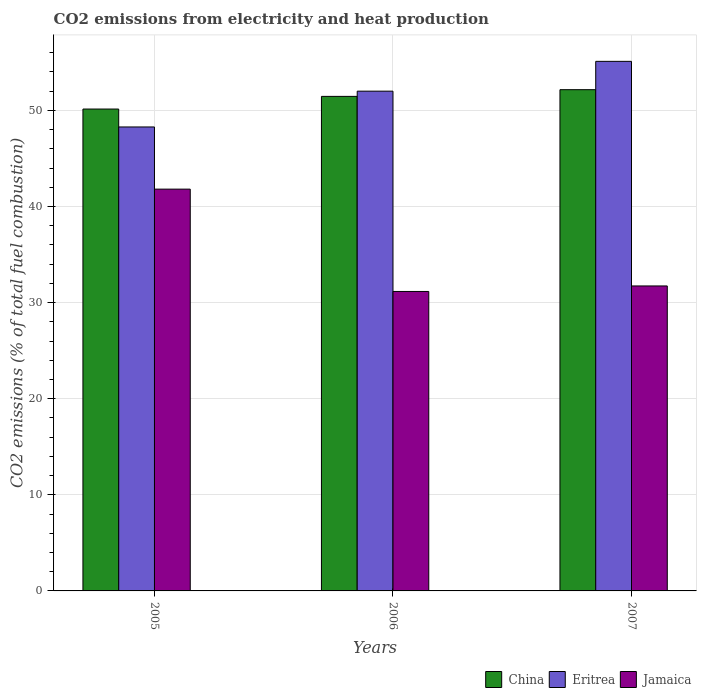How many groups of bars are there?
Offer a very short reply. 3. Are the number of bars on each tick of the X-axis equal?
Your response must be concise. Yes. How many bars are there on the 1st tick from the right?
Your response must be concise. 3. What is the label of the 1st group of bars from the left?
Make the answer very short. 2005. What is the amount of CO2 emitted in China in 2006?
Your response must be concise. 51.46. Across all years, what is the maximum amount of CO2 emitted in Eritrea?
Offer a very short reply. 55.1. Across all years, what is the minimum amount of CO2 emitted in Eritrea?
Provide a short and direct response. 48.28. In which year was the amount of CO2 emitted in China minimum?
Ensure brevity in your answer.  2005. What is the total amount of CO2 emitted in Eritrea in the graph?
Offer a terse response. 155.38. What is the difference between the amount of CO2 emitted in China in 2006 and that in 2007?
Provide a short and direct response. -0.7. What is the difference between the amount of CO2 emitted in Jamaica in 2005 and the amount of CO2 emitted in Eritrea in 2006?
Provide a short and direct response. -10.19. What is the average amount of CO2 emitted in China per year?
Your answer should be very brief. 51.25. In the year 2007, what is the difference between the amount of CO2 emitted in Eritrea and amount of CO2 emitted in China?
Your answer should be compact. 2.95. What is the ratio of the amount of CO2 emitted in Eritrea in 2005 to that in 2007?
Your answer should be compact. 0.88. Is the difference between the amount of CO2 emitted in Eritrea in 2005 and 2007 greater than the difference between the amount of CO2 emitted in China in 2005 and 2007?
Keep it short and to the point. No. What is the difference between the highest and the second highest amount of CO2 emitted in Eritrea?
Offer a very short reply. 3.1. What is the difference between the highest and the lowest amount of CO2 emitted in Jamaica?
Provide a short and direct response. 10.65. What does the 3rd bar from the left in 2006 represents?
Offer a terse response. Jamaica. What does the 1st bar from the right in 2006 represents?
Your answer should be very brief. Jamaica. What is the difference between two consecutive major ticks on the Y-axis?
Your answer should be compact. 10. Does the graph contain grids?
Give a very brief answer. Yes. How are the legend labels stacked?
Keep it short and to the point. Horizontal. What is the title of the graph?
Offer a terse response. CO2 emissions from electricity and heat production. Does "Middle East & North Africa (all income levels)" appear as one of the legend labels in the graph?
Your answer should be very brief. No. What is the label or title of the Y-axis?
Offer a terse response. CO2 emissions (% of total fuel combustion). What is the CO2 emissions (% of total fuel combustion) in China in 2005?
Offer a very short reply. 50.14. What is the CO2 emissions (% of total fuel combustion) of Eritrea in 2005?
Give a very brief answer. 48.28. What is the CO2 emissions (% of total fuel combustion) in Jamaica in 2005?
Offer a terse response. 41.81. What is the CO2 emissions (% of total fuel combustion) of China in 2006?
Your response must be concise. 51.46. What is the CO2 emissions (% of total fuel combustion) in Eritrea in 2006?
Your answer should be very brief. 52. What is the CO2 emissions (% of total fuel combustion) of Jamaica in 2006?
Make the answer very short. 31.16. What is the CO2 emissions (% of total fuel combustion) of China in 2007?
Keep it short and to the point. 52.15. What is the CO2 emissions (% of total fuel combustion) of Eritrea in 2007?
Give a very brief answer. 55.1. What is the CO2 emissions (% of total fuel combustion) of Jamaica in 2007?
Give a very brief answer. 31.73. Across all years, what is the maximum CO2 emissions (% of total fuel combustion) of China?
Offer a terse response. 52.15. Across all years, what is the maximum CO2 emissions (% of total fuel combustion) in Eritrea?
Offer a very short reply. 55.1. Across all years, what is the maximum CO2 emissions (% of total fuel combustion) in Jamaica?
Give a very brief answer. 41.81. Across all years, what is the minimum CO2 emissions (% of total fuel combustion) in China?
Your answer should be compact. 50.14. Across all years, what is the minimum CO2 emissions (% of total fuel combustion) in Eritrea?
Make the answer very short. 48.28. Across all years, what is the minimum CO2 emissions (% of total fuel combustion) of Jamaica?
Keep it short and to the point. 31.16. What is the total CO2 emissions (% of total fuel combustion) of China in the graph?
Provide a short and direct response. 153.75. What is the total CO2 emissions (% of total fuel combustion) of Eritrea in the graph?
Offer a very short reply. 155.38. What is the total CO2 emissions (% of total fuel combustion) in Jamaica in the graph?
Offer a very short reply. 104.7. What is the difference between the CO2 emissions (% of total fuel combustion) in China in 2005 and that in 2006?
Your answer should be compact. -1.32. What is the difference between the CO2 emissions (% of total fuel combustion) of Eritrea in 2005 and that in 2006?
Offer a terse response. -3.72. What is the difference between the CO2 emissions (% of total fuel combustion) in Jamaica in 2005 and that in 2006?
Make the answer very short. 10.65. What is the difference between the CO2 emissions (% of total fuel combustion) of China in 2005 and that in 2007?
Give a very brief answer. -2.02. What is the difference between the CO2 emissions (% of total fuel combustion) of Eritrea in 2005 and that in 2007?
Your answer should be very brief. -6.83. What is the difference between the CO2 emissions (% of total fuel combustion) in Jamaica in 2005 and that in 2007?
Ensure brevity in your answer.  10.07. What is the difference between the CO2 emissions (% of total fuel combustion) of China in 2006 and that in 2007?
Provide a succinct answer. -0.7. What is the difference between the CO2 emissions (% of total fuel combustion) of Eritrea in 2006 and that in 2007?
Your answer should be compact. -3.1. What is the difference between the CO2 emissions (% of total fuel combustion) of Jamaica in 2006 and that in 2007?
Offer a very short reply. -0.57. What is the difference between the CO2 emissions (% of total fuel combustion) in China in 2005 and the CO2 emissions (% of total fuel combustion) in Eritrea in 2006?
Keep it short and to the point. -1.86. What is the difference between the CO2 emissions (% of total fuel combustion) in China in 2005 and the CO2 emissions (% of total fuel combustion) in Jamaica in 2006?
Your answer should be very brief. 18.98. What is the difference between the CO2 emissions (% of total fuel combustion) in Eritrea in 2005 and the CO2 emissions (% of total fuel combustion) in Jamaica in 2006?
Offer a very short reply. 17.12. What is the difference between the CO2 emissions (% of total fuel combustion) in China in 2005 and the CO2 emissions (% of total fuel combustion) in Eritrea in 2007?
Provide a short and direct response. -4.96. What is the difference between the CO2 emissions (% of total fuel combustion) of China in 2005 and the CO2 emissions (% of total fuel combustion) of Jamaica in 2007?
Make the answer very short. 18.41. What is the difference between the CO2 emissions (% of total fuel combustion) of Eritrea in 2005 and the CO2 emissions (% of total fuel combustion) of Jamaica in 2007?
Ensure brevity in your answer.  16.54. What is the difference between the CO2 emissions (% of total fuel combustion) in China in 2006 and the CO2 emissions (% of total fuel combustion) in Eritrea in 2007?
Keep it short and to the point. -3.64. What is the difference between the CO2 emissions (% of total fuel combustion) in China in 2006 and the CO2 emissions (% of total fuel combustion) in Jamaica in 2007?
Offer a very short reply. 19.72. What is the difference between the CO2 emissions (% of total fuel combustion) in Eritrea in 2006 and the CO2 emissions (% of total fuel combustion) in Jamaica in 2007?
Offer a very short reply. 20.27. What is the average CO2 emissions (% of total fuel combustion) of China per year?
Provide a succinct answer. 51.25. What is the average CO2 emissions (% of total fuel combustion) of Eritrea per year?
Keep it short and to the point. 51.79. What is the average CO2 emissions (% of total fuel combustion) of Jamaica per year?
Make the answer very short. 34.9. In the year 2005, what is the difference between the CO2 emissions (% of total fuel combustion) of China and CO2 emissions (% of total fuel combustion) of Eritrea?
Give a very brief answer. 1.86. In the year 2005, what is the difference between the CO2 emissions (% of total fuel combustion) in China and CO2 emissions (% of total fuel combustion) in Jamaica?
Provide a short and direct response. 8.33. In the year 2005, what is the difference between the CO2 emissions (% of total fuel combustion) of Eritrea and CO2 emissions (% of total fuel combustion) of Jamaica?
Ensure brevity in your answer.  6.47. In the year 2006, what is the difference between the CO2 emissions (% of total fuel combustion) of China and CO2 emissions (% of total fuel combustion) of Eritrea?
Keep it short and to the point. -0.54. In the year 2006, what is the difference between the CO2 emissions (% of total fuel combustion) in China and CO2 emissions (% of total fuel combustion) in Jamaica?
Ensure brevity in your answer.  20.3. In the year 2006, what is the difference between the CO2 emissions (% of total fuel combustion) in Eritrea and CO2 emissions (% of total fuel combustion) in Jamaica?
Provide a succinct answer. 20.84. In the year 2007, what is the difference between the CO2 emissions (% of total fuel combustion) of China and CO2 emissions (% of total fuel combustion) of Eritrea?
Offer a terse response. -2.95. In the year 2007, what is the difference between the CO2 emissions (% of total fuel combustion) in China and CO2 emissions (% of total fuel combustion) in Jamaica?
Give a very brief answer. 20.42. In the year 2007, what is the difference between the CO2 emissions (% of total fuel combustion) in Eritrea and CO2 emissions (% of total fuel combustion) in Jamaica?
Your answer should be very brief. 23.37. What is the ratio of the CO2 emissions (% of total fuel combustion) of China in 2005 to that in 2006?
Make the answer very short. 0.97. What is the ratio of the CO2 emissions (% of total fuel combustion) in Eritrea in 2005 to that in 2006?
Provide a succinct answer. 0.93. What is the ratio of the CO2 emissions (% of total fuel combustion) in Jamaica in 2005 to that in 2006?
Your response must be concise. 1.34. What is the ratio of the CO2 emissions (% of total fuel combustion) in China in 2005 to that in 2007?
Provide a short and direct response. 0.96. What is the ratio of the CO2 emissions (% of total fuel combustion) in Eritrea in 2005 to that in 2007?
Provide a succinct answer. 0.88. What is the ratio of the CO2 emissions (% of total fuel combustion) of Jamaica in 2005 to that in 2007?
Your answer should be compact. 1.32. What is the ratio of the CO2 emissions (% of total fuel combustion) of China in 2006 to that in 2007?
Offer a very short reply. 0.99. What is the ratio of the CO2 emissions (% of total fuel combustion) of Eritrea in 2006 to that in 2007?
Keep it short and to the point. 0.94. What is the ratio of the CO2 emissions (% of total fuel combustion) in Jamaica in 2006 to that in 2007?
Offer a very short reply. 0.98. What is the difference between the highest and the second highest CO2 emissions (% of total fuel combustion) in China?
Your answer should be compact. 0.7. What is the difference between the highest and the second highest CO2 emissions (% of total fuel combustion) of Eritrea?
Make the answer very short. 3.1. What is the difference between the highest and the second highest CO2 emissions (% of total fuel combustion) in Jamaica?
Your answer should be very brief. 10.07. What is the difference between the highest and the lowest CO2 emissions (% of total fuel combustion) of China?
Provide a short and direct response. 2.02. What is the difference between the highest and the lowest CO2 emissions (% of total fuel combustion) of Eritrea?
Make the answer very short. 6.83. What is the difference between the highest and the lowest CO2 emissions (% of total fuel combustion) of Jamaica?
Make the answer very short. 10.65. 